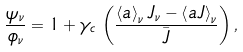Convert formula to latex. <formula><loc_0><loc_0><loc_500><loc_500>\frac { \psi _ { \nu } } { \phi _ { \nu } } = 1 + \gamma _ { c } \, \left ( \frac { \left < a \right > _ { \nu } J _ { \nu } - \left < a J \right > _ { \nu } } { \bar { J } } \right ) ,</formula> 